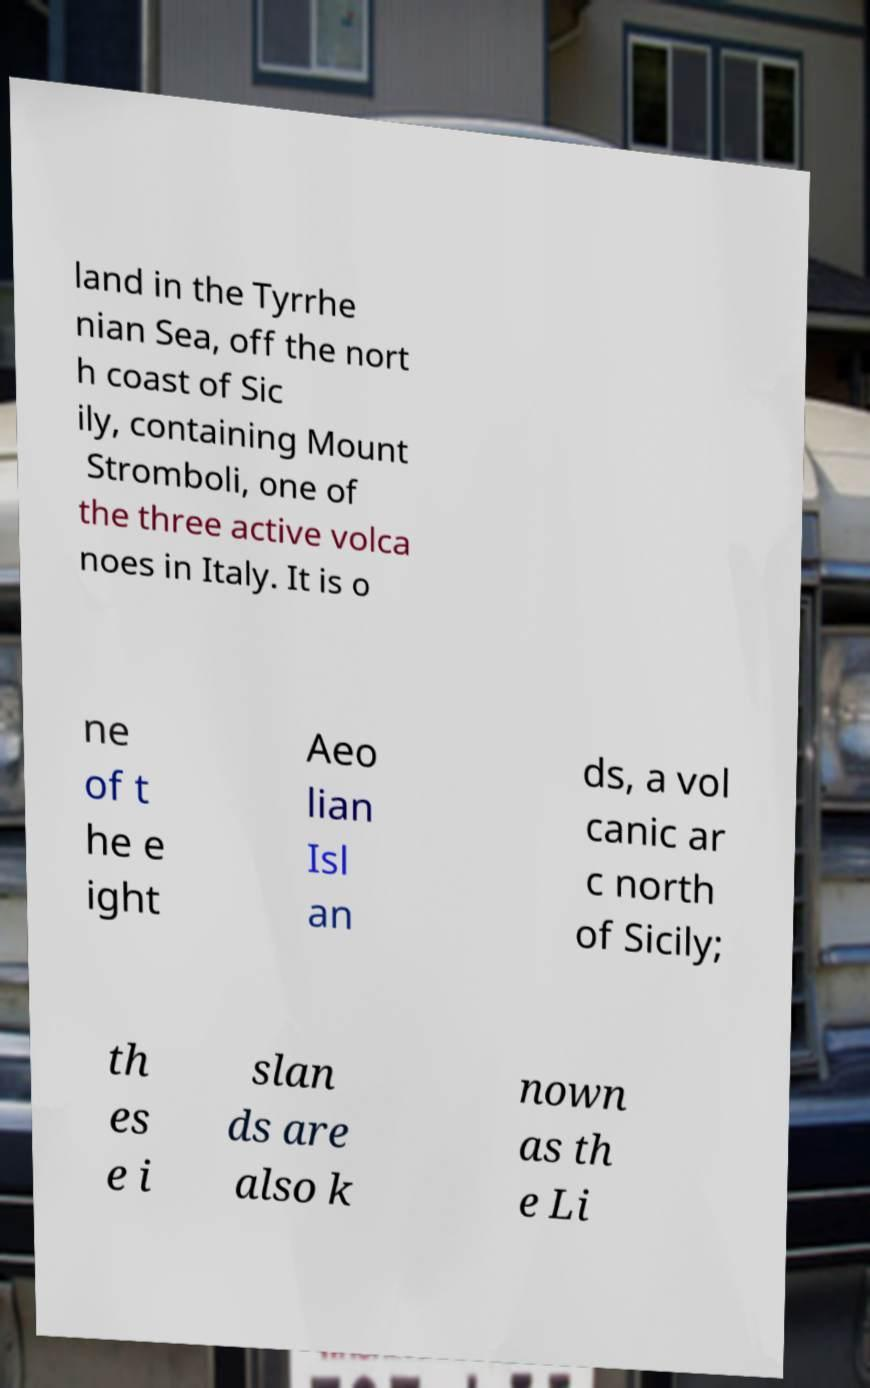Could you extract and type out the text from this image? land in the Tyrrhe nian Sea, off the nort h coast of Sic ily, containing Mount Stromboli, one of the three active volca noes in Italy. It is o ne of t he e ight Aeo lian Isl an ds, a vol canic ar c north of Sicily; th es e i slan ds are also k nown as th e Li 